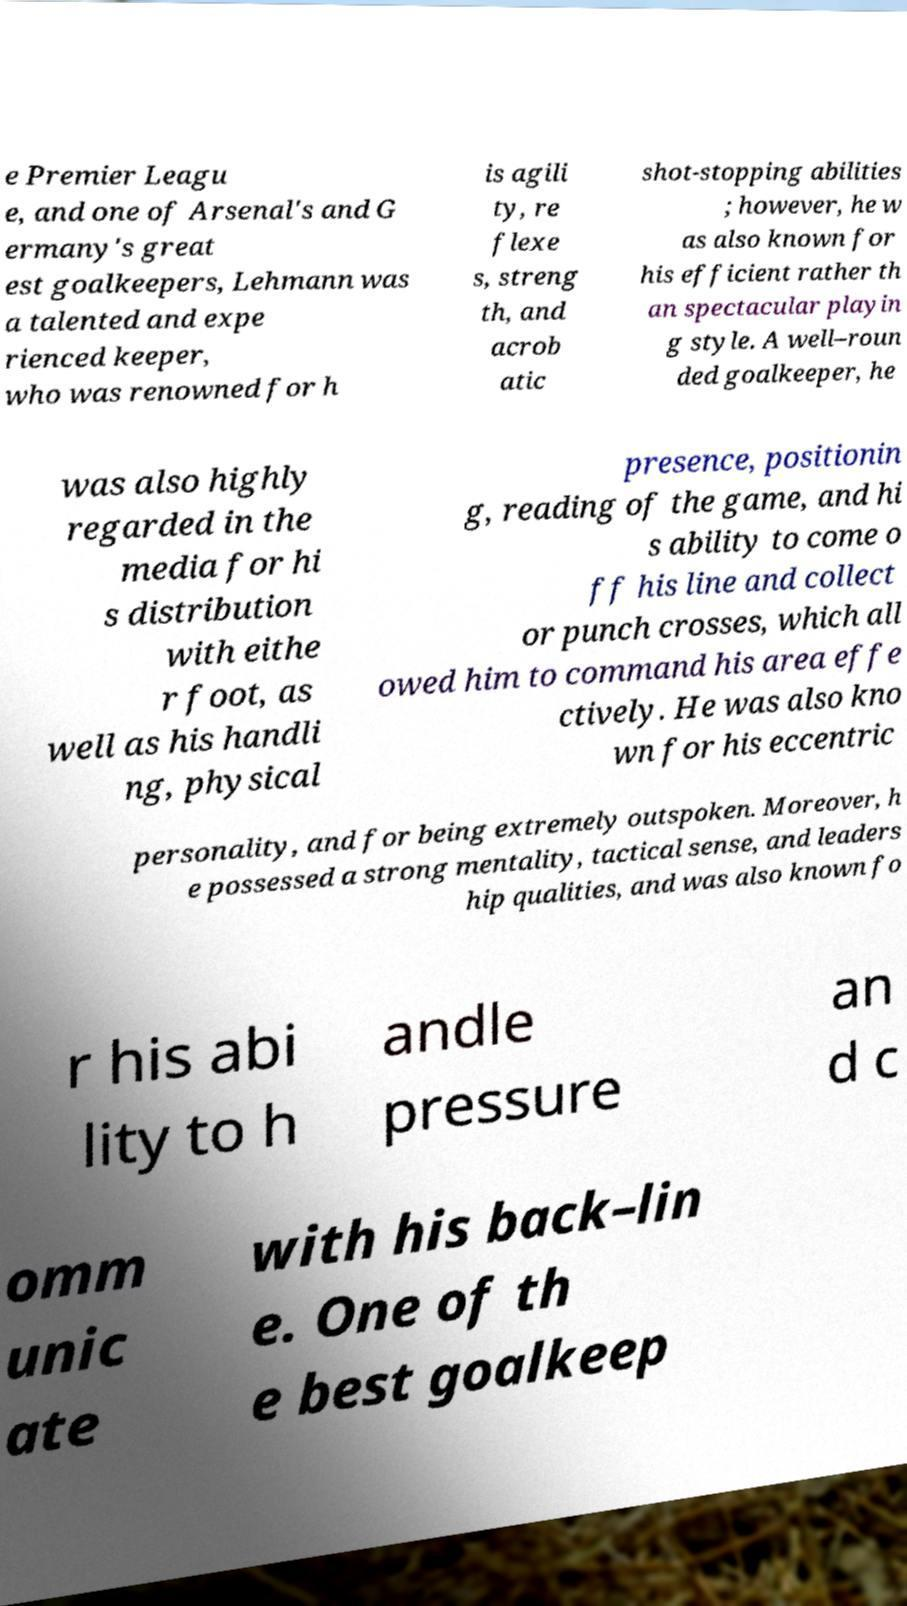I need the written content from this picture converted into text. Can you do that? e Premier Leagu e, and one of Arsenal's and G ermany's great est goalkeepers, Lehmann was a talented and expe rienced keeper, who was renowned for h is agili ty, re flexe s, streng th, and acrob atic shot-stopping abilities ; however, he w as also known for his efficient rather th an spectacular playin g style. A well–roun ded goalkeeper, he was also highly regarded in the media for hi s distribution with eithe r foot, as well as his handli ng, physical presence, positionin g, reading of the game, and hi s ability to come o ff his line and collect or punch crosses, which all owed him to command his area effe ctively. He was also kno wn for his eccentric personality, and for being extremely outspoken. Moreover, h e possessed a strong mentality, tactical sense, and leaders hip qualities, and was also known fo r his abi lity to h andle pressure an d c omm unic ate with his back–lin e. One of th e best goalkeep 